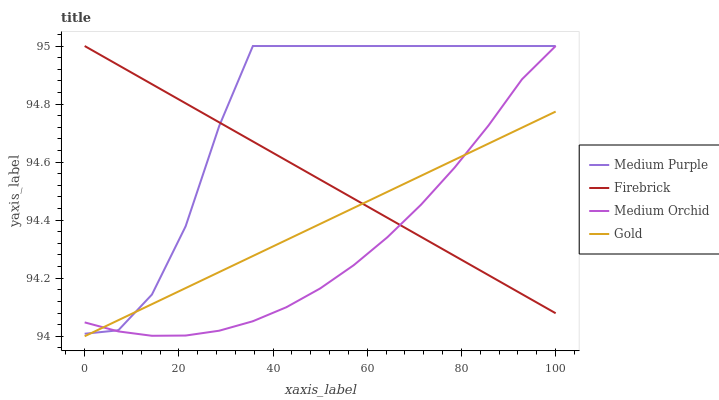Does Firebrick have the minimum area under the curve?
Answer yes or no. No. Does Firebrick have the maximum area under the curve?
Answer yes or no. No. Is Firebrick the smoothest?
Answer yes or no. No. Is Firebrick the roughest?
Answer yes or no. No. Does Medium Orchid have the lowest value?
Answer yes or no. No. Does Gold have the highest value?
Answer yes or no. No. 